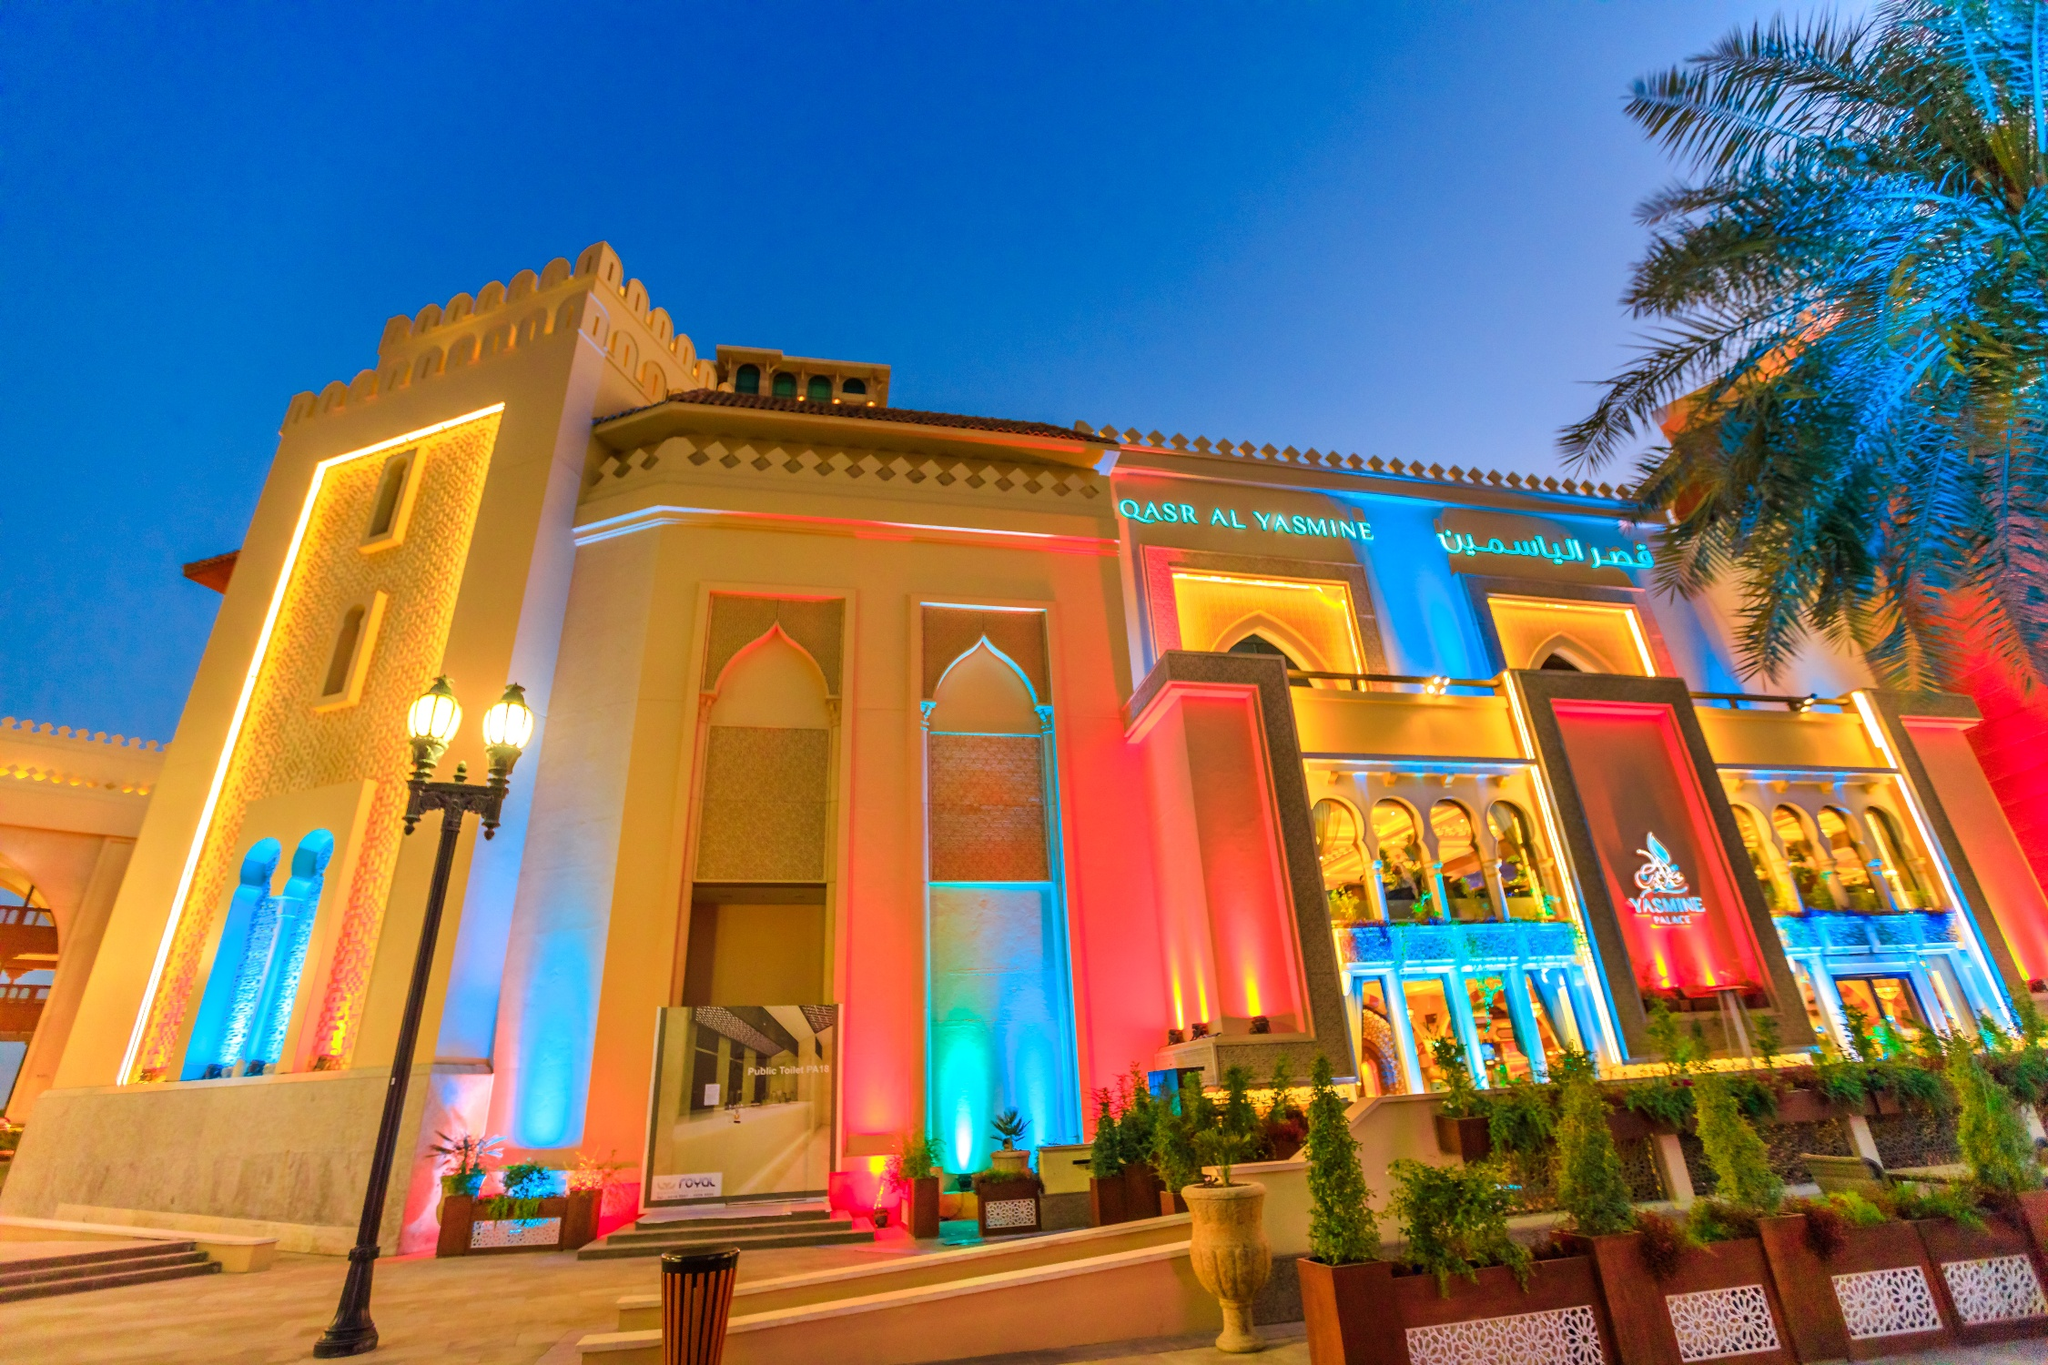Analyze the image in a comprehensive and detailed manner. The image features Qasr Al Watan, an iconic palace in Abu Dhabi, United Arab Emirates, known for its architectural magnificence and cultural significance. The palace, an epitome of modern Arabian architecture, is illuminated brilliantly with a spectrum of colors, highlighting intricate details on the facade that blend traditional designs with contemporary artistry. This lighting not only accentuates the grandeur of the architectural elements but also symbolizes the vibrant cultural heritage the palace preserves. Set against a twilight sky, the scene is framed with lush palm trees, subtly lit to complement the palace's radiance. This multi-colored illumination adds a festive and welcoming atmosphere, inviting onlookers to appreciate the fusion of history with modernity that the palace represents. Overall, the image serves as a dazzling homage to both the architectural prowess and the cultural richness of Abu Dhabi. 